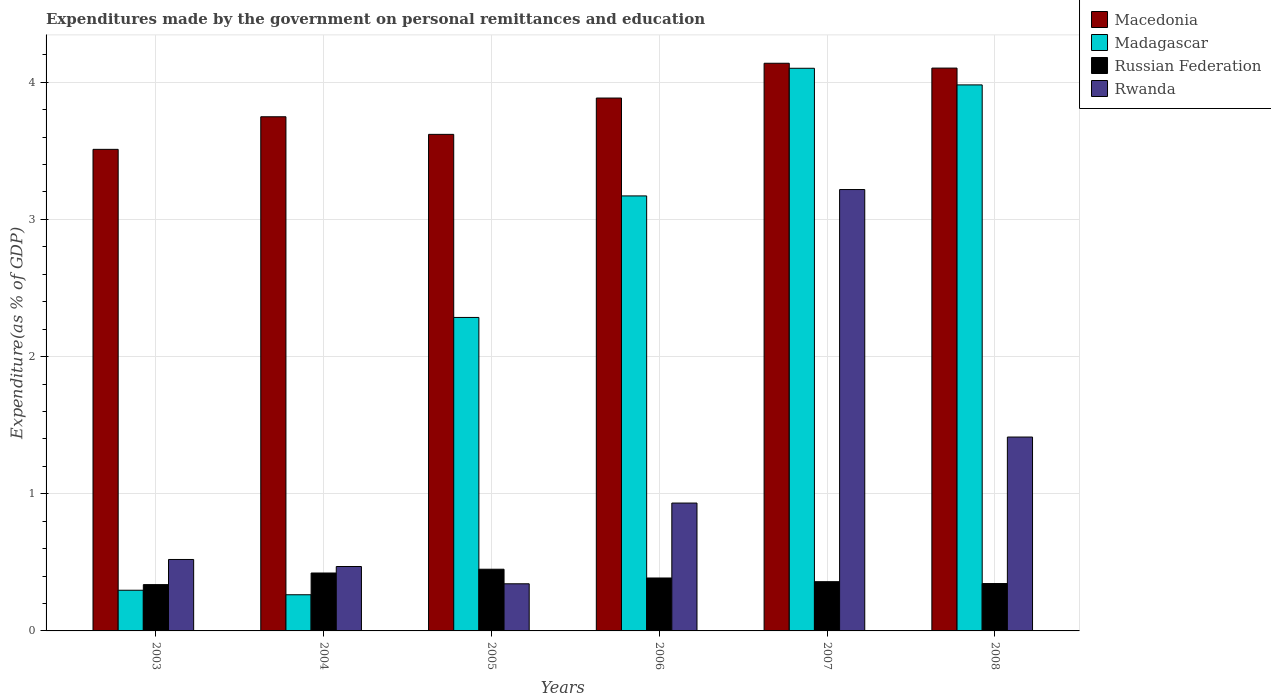How many different coloured bars are there?
Provide a succinct answer. 4. How many groups of bars are there?
Your answer should be compact. 6. How many bars are there on the 1st tick from the right?
Your answer should be very brief. 4. What is the expenditures made by the government on personal remittances and education in Rwanda in 2008?
Keep it short and to the point. 1.41. Across all years, what is the maximum expenditures made by the government on personal remittances and education in Macedonia?
Your response must be concise. 4.14. Across all years, what is the minimum expenditures made by the government on personal remittances and education in Rwanda?
Make the answer very short. 0.34. What is the total expenditures made by the government on personal remittances and education in Rwanda in the graph?
Offer a terse response. 6.9. What is the difference between the expenditures made by the government on personal remittances and education in Russian Federation in 2003 and that in 2008?
Your answer should be compact. -0.01. What is the difference between the expenditures made by the government on personal remittances and education in Russian Federation in 2005 and the expenditures made by the government on personal remittances and education in Madagascar in 2004?
Provide a short and direct response. 0.19. What is the average expenditures made by the government on personal remittances and education in Macedonia per year?
Offer a very short reply. 3.83. In the year 2008, what is the difference between the expenditures made by the government on personal remittances and education in Macedonia and expenditures made by the government on personal remittances and education in Madagascar?
Provide a short and direct response. 0.12. What is the ratio of the expenditures made by the government on personal remittances and education in Russian Federation in 2003 to that in 2004?
Give a very brief answer. 0.8. Is the difference between the expenditures made by the government on personal remittances and education in Macedonia in 2003 and 2006 greater than the difference between the expenditures made by the government on personal remittances and education in Madagascar in 2003 and 2006?
Provide a succinct answer. Yes. What is the difference between the highest and the second highest expenditures made by the government on personal remittances and education in Rwanda?
Ensure brevity in your answer.  1.8. What is the difference between the highest and the lowest expenditures made by the government on personal remittances and education in Russian Federation?
Give a very brief answer. 0.11. What does the 4th bar from the left in 2003 represents?
Keep it short and to the point. Rwanda. What does the 3rd bar from the right in 2006 represents?
Your answer should be compact. Madagascar. Are all the bars in the graph horizontal?
Offer a terse response. No. How many years are there in the graph?
Your response must be concise. 6. Are the values on the major ticks of Y-axis written in scientific E-notation?
Your answer should be very brief. No. Where does the legend appear in the graph?
Make the answer very short. Top right. What is the title of the graph?
Your response must be concise. Expenditures made by the government on personal remittances and education. Does "Malawi" appear as one of the legend labels in the graph?
Your answer should be very brief. No. What is the label or title of the Y-axis?
Ensure brevity in your answer.  Expenditure(as % of GDP). What is the Expenditure(as % of GDP) of Macedonia in 2003?
Your answer should be compact. 3.51. What is the Expenditure(as % of GDP) in Madagascar in 2003?
Your answer should be compact. 0.3. What is the Expenditure(as % of GDP) of Russian Federation in 2003?
Your response must be concise. 0.34. What is the Expenditure(as % of GDP) in Rwanda in 2003?
Make the answer very short. 0.52. What is the Expenditure(as % of GDP) of Macedonia in 2004?
Your response must be concise. 3.75. What is the Expenditure(as % of GDP) in Madagascar in 2004?
Provide a succinct answer. 0.26. What is the Expenditure(as % of GDP) in Russian Federation in 2004?
Make the answer very short. 0.42. What is the Expenditure(as % of GDP) in Rwanda in 2004?
Offer a terse response. 0.47. What is the Expenditure(as % of GDP) in Macedonia in 2005?
Make the answer very short. 3.62. What is the Expenditure(as % of GDP) of Madagascar in 2005?
Your response must be concise. 2.29. What is the Expenditure(as % of GDP) in Russian Federation in 2005?
Your response must be concise. 0.45. What is the Expenditure(as % of GDP) in Rwanda in 2005?
Make the answer very short. 0.34. What is the Expenditure(as % of GDP) in Macedonia in 2006?
Give a very brief answer. 3.88. What is the Expenditure(as % of GDP) in Madagascar in 2006?
Offer a very short reply. 3.17. What is the Expenditure(as % of GDP) in Russian Federation in 2006?
Your response must be concise. 0.39. What is the Expenditure(as % of GDP) of Rwanda in 2006?
Keep it short and to the point. 0.93. What is the Expenditure(as % of GDP) of Macedonia in 2007?
Make the answer very short. 4.14. What is the Expenditure(as % of GDP) of Madagascar in 2007?
Keep it short and to the point. 4.1. What is the Expenditure(as % of GDP) in Russian Federation in 2007?
Offer a very short reply. 0.36. What is the Expenditure(as % of GDP) of Rwanda in 2007?
Your answer should be compact. 3.22. What is the Expenditure(as % of GDP) of Macedonia in 2008?
Your answer should be compact. 4.1. What is the Expenditure(as % of GDP) in Madagascar in 2008?
Your answer should be compact. 3.98. What is the Expenditure(as % of GDP) of Russian Federation in 2008?
Your response must be concise. 0.35. What is the Expenditure(as % of GDP) in Rwanda in 2008?
Make the answer very short. 1.41. Across all years, what is the maximum Expenditure(as % of GDP) in Macedonia?
Offer a terse response. 4.14. Across all years, what is the maximum Expenditure(as % of GDP) in Madagascar?
Ensure brevity in your answer.  4.1. Across all years, what is the maximum Expenditure(as % of GDP) in Russian Federation?
Your response must be concise. 0.45. Across all years, what is the maximum Expenditure(as % of GDP) of Rwanda?
Provide a short and direct response. 3.22. Across all years, what is the minimum Expenditure(as % of GDP) of Macedonia?
Provide a short and direct response. 3.51. Across all years, what is the minimum Expenditure(as % of GDP) of Madagascar?
Offer a terse response. 0.26. Across all years, what is the minimum Expenditure(as % of GDP) of Russian Federation?
Offer a very short reply. 0.34. Across all years, what is the minimum Expenditure(as % of GDP) of Rwanda?
Make the answer very short. 0.34. What is the total Expenditure(as % of GDP) in Macedonia in the graph?
Your answer should be compact. 23.01. What is the total Expenditure(as % of GDP) in Madagascar in the graph?
Your response must be concise. 14.1. What is the total Expenditure(as % of GDP) in Russian Federation in the graph?
Provide a short and direct response. 2.3. What is the total Expenditure(as % of GDP) of Rwanda in the graph?
Offer a terse response. 6.9. What is the difference between the Expenditure(as % of GDP) in Macedonia in 2003 and that in 2004?
Your answer should be very brief. -0.24. What is the difference between the Expenditure(as % of GDP) of Madagascar in 2003 and that in 2004?
Provide a succinct answer. 0.03. What is the difference between the Expenditure(as % of GDP) of Russian Federation in 2003 and that in 2004?
Offer a terse response. -0.08. What is the difference between the Expenditure(as % of GDP) of Rwanda in 2003 and that in 2004?
Ensure brevity in your answer.  0.05. What is the difference between the Expenditure(as % of GDP) of Macedonia in 2003 and that in 2005?
Offer a terse response. -0.11. What is the difference between the Expenditure(as % of GDP) in Madagascar in 2003 and that in 2005?
Keep it short and to the point. -1.99. What is the difference between the Expenditure(as % of GDP) in Russian Federation in 2003 and that in 2005?
Provide a short and direct response. -0.11. What is the difference between the Expenditure(as % of GDP) in Rwanda in 2003 and that in 2005?
Offer a very short reply. 0.18. What is the difference between the Expenditure(as % of GDP) in Macedonia in 2003 and that in 2006?
Provide a short and direct response. -0.37. What is the difference between the Expenditure(as % of GDP) in Madagascar in 2003 and that in 2006?
Provide a succinct answer. -2.87. What is the difference between the Expenditure(as % of GDP) in Russian Federation in 2003 and that in 2006?
Make the answer very short. -0.05. What is the difference between the Expenditure(as % of GDP) of Rwanda in 2003 and that in 2006?
Ensure brevity in your answer.  -0.41. What is the difference between the Expenditure(as % of GDP) of Macedonia in 2003 and that in 2007?
Provide a succinct answer. -0.63. What is the difference between the Expenditure(as % of GDP) of Madagascar in 2003 and that in 2007?
Provide a succinct answer. -3.81. What is the difference between the Expenditure(as % of GDP) in Russian Federation in 2003 and that in 2007?
Give a very brief answer. -0.02. What is the difference between the Expenditure(as % of GDP) in Rwanda in 2003 and that in 2007?
Your response must be concise. -2.7. What is the difference between the Expenditure(as % of GDP) in Macedonia in 2003 and that in 2008?
Your answer should be compact. -0.59. What is the difference between the Expenditure(as % of GDP) of Madagascar in 2003 and that in 2008?
Offer a very short reply. -3.68. What is the difference between the Expenditure(as % of GDP) of Russian Federation in 2003 and that in 2008?
Keep it short and to the point. -0.01. What is the difference between the Expenditure(as % of GDP) in Rwanda in 2003 and that in 2008?
Your answer should be compact. -0.89. What is the difference between the Expenditure(as % of GDP) in Macedonia in 2004 and that in 2005?
Your answer should be compact. 0.13. What is the difference between the Expenditure(as % of GDP) of Madagascar in 2004 and that in 2005?
Your answer should be very brief. -2.02. What is the difference between the Expenditure(as % of GDP) of Russian Federation in 2004 and that in 2005?
Your answer should be very brief. -0.03. What is the difference between the Expenditure(as % of GDP) in Rwanda in 2004 and that in 2005?
Provide a short and direct response. 0.13. What is the difference between the Expenditure(as % of GDP) of Macedonia in 2004 and that in 2006?
Your answer should be compact. -0.14. What is the difference between the Expenditure(as % of GDP) in Madagascar in 2004 and that in 2006?
Give a very brief answer. -2.91. What is the difference between the Expenditure(as % of GDP) in Russian Federation in 2004 and that in 2006?
Your response must be concise. 0.04. What is the difference between the Expenditure(as % of GDP) in Rwanda in 2004 and that in 2006?
Give a very brief answer. -0.46. What is the difference between the Expenditure(as % of GDP) in Macedonia in 2004 and that in 2007?
Offer a terse response. -0.39. What is the difference between the Expenditure(as % of GDP) in Madagascar in 2004 and that in 2007?
Ensure brevity in your answer.  -3.84. What is the difference between the Expenditure(as % of GDP) in Russian Federation in 2004 and that in 2007?
Give a very brief answer. 0.06. What is the difference between the Expenditure(as % of GDP) in Rwanda in 2004 and that in 2007?
Ensure brevity in your answer.  -2.75. What is the difference between the Expenditure(as % of GDP) in Macedonia in 2004 and that in 2008?
Your response must be concise. -0.35. What is the difference between the Expenditure(as % of GDP) of Madagascar in 2004 and that in 2008?
Your response must be concise. -3.72. What is the difference between the Expenditure(as % of GDP) in Russian Federation in 2004 and that in 2008?
Your answer should be very brief. 0.08. What is the difference between the Expenditure(as % of GDP) of Rwanda in 2004 and that in 2008?
Make the answer very short. -0.94. What is the difference between the Expenditure(as % of GDP) of Macedonia in 2005 and that in 2006?
Your answer should be compact. -0.26. What is the difference between the Expenditure(as % of GDP) in Madagascar in 2005 and that in 2006?
Your answer should be very brief. -0.89. What is the difference between the Expenditure(as % of GDP) of Russian Federation in 2005 and that in 2006?
Ensure brevity in your answer.  0.06. What is the difference between the Expenditure(as % of GDP) of Rwanda in 2005 and that in 2006?
Provide a short and direct response. -0.59. What is the difference between the Expenditure(as % of GDP) in Macedonia in 2005 and that in 2007?
Offer a terse response. -0.52. What is the difference between the Expenditure(as % of GDP) in Madagascar in 2005 and that in 2007?
Provide a short and direct response. -1.82. What is the difference between the Expenditure(as % of GDP) of Russian Federation in 2005 and that in 2007?
Offer a terse response. 0.09. What is the difference between the Expenditure(as % of GDP) in Rwanda in 2005 and that in 2007?
Provide a succinct answer. -2.87. What is the difference between the Expenditure(as % of GDP) in Macedonia in 2005 and that in 2008?
Your answer should be compact. -0.48. What is the difference between the Expenditure(as % of GDP) in Madagascar in 2005 and that in 2008?
Provide a short and direct response. -1.7. What is the difference between the Expenditure(as % of GDP) of Russian Federation in 2005 and that in 2008?
Make the answer very short. 0.1. What is the difference between the Expenditure(as % of GDP) of Rwanda in 2005 and that in 2008?
Offer a very short reply. -1.07. What is the difference between the Expenditure(as % of GDP) in Macedonia in 2006 and that in 2007?
Offer a very short reply. -0.25. What is the difference between the Expenditure(as % of GDP) of Madagascar in 2006 and that in 2007?
Offer a terse response. -0.93. What is the difference between the Expenditure(as % of GDP) in Russian Federation in 2006 and that in 2007?
Make the answer very short. 0.03. What is the difference between the Expenditure(as % of GDP) of Rwanda in 2006 and that in 2007?
Offer a terse response. -2.29. What is the difference between the Expenditure(as % of GDP) in Macedonia in 2006 and that in 2008?
Give a very brief answer. -0.22. What is the difference between the Expenditure(as % of GDP) in Madagascar in 2006 and that in 2008?
Your answer should be very brief. -0.81. What is the difference between the Expenditure(as % of GDP) of Russian Federation in 2006 and that in 2008?
Your response must be concise. 0.04. What is the difference between the Expenditure(as % of GDP) in Rwanda in 2006 and that in 2008?
Ensure brevity in your answer.  -0.48. What is the difference between the Expenditure(as % of GDP) of Macedonia in 2007 and that in 2008?
Provide a short and direct response. 0.04. What is the difference between the Expenditure(as % of GDP) in Madagascar in 2007 and that in 2008?
Offer a very short reply. 0.12. What is the difference between the Expenditure(as % of GDP) of Russian Federation in 2007 and that in 2008?
Offer a very short reply. 0.01. What is the difference between the Expenditure(as % of GDP) in Rwanda in 2007 and that in 2008?
Your response must be concise. 1.8. What is the difference between the Expenditure(as % of GDP) in Macedonia in 2003 and the Expenditure(as % of GDP) in Madagascar in 2004?
Your response must be concise. 3.25. What is the difference between the Expenditure(as % of GDP) in Macedonia in 2003 and the Expenditure(as % of GDP) in Russian Federation in 2004?
Provide a short and direct response. 3.09. What is the difference between the Expenditure(as % of GDP) in Macedonia in 2003 and the Expenditure(as % of GDP) in Rwanda in 2004?
Your answer should be very brief. 3.04. What is the difference between the Expenditure(as % of GDP) of Madagascar in 2003 and the Expenditure(as % of GDP) of Russian Federation in 2004?
Offer a terse response. -0.13. What is the difference between the Expenditure(as % of GDP) of Madagascar in 2003 and the Expenditure(as % of GDP) of Rwanda in 2004?
Offer a very short reply. -0.17. What is the difference between the Expenditure(as % of GDP) in Russian Federation in 2003 and the Expenditure(as % of GDP) in Rwanda in 2004?
Offer a terse response. -0.13. What is the difference between the Expenditure(as % of GDP) of Macedonia in 2003 and the Expenditure(as % of GDP) of Madagascar in 2005?
Provide a short and direct response. 1.23. What is the difference between the Expenditure(as % of GDP) in Macedonia in 2003 and the Expenditure(as % of GDP) in Russian Federation in 2005?
Make the answer very short. 3.06. What is the difference between the Expenditure(as % of GDP) in Macedonia in 2003 and the Expenditure(as % of GDP) in Rwanda in 2005?
Your answer should be compact. 3.17. What is the difference between the Expenditure(as % of GDP) in Madagascar in 2003 and the Expenditure(as % of GDP) in Russian Federation in 2005?
Your answer should be compact. -0.15. What is the difference between the Expenditure(as % of GDP) in Madagascar in 2003 and the Expenditure(as % of GDP) in Rwanda in 2005?
Your answer should be compact. -0.05. What is the difference between the Expenditure(as % of GDP) of Russian Federation in 2003 and the Expenditure(as % of GDP) of Rwanda in 2005?
Make the answer very short. -0.01. What is the difference between the Expenditure(as % of GDP) of Macedonia in 2003 and the Expenditure(as % of GDP) of Madagascar in 2006?
Your answer should be very brief. 0.34. What is the difference between the Expenditure(as % of GDP) in Macedonia in 2003 and the Expenditure(as % of GDP) in Russian Federation in 2006?
Make the answer very short. 3.12. What is the difference between the Expenditure(as % of GDP) in Macedonia in 2003 and the Expenditure(as % of GDP) in Rwanda in 2006?
Your answer should be very brief. 2.58. What is the difference between the Expenditure(as % of GDP) in Madagascar in 2003 and the Expenditure(as % of GDP) in Russian Federation in 2006?
Give a very brief answer. -0.09. What is the difference between the Expenditure(as % of GDP) in Madagascar in 2003 and the Expenditure(as % of GDP) in Rwanda in 2006?
Offer a terse response. -0.64. What is the difference between the Expenditure(as % of GDP) of Russian Federation in 2003 and the Expenditure(as % of GDP) of Rwanda in 2006?
Your answer should be very brief. -0.59. What is the difference between the Expenditure(as % of GDP) of Macedonia in 2003 and the Expenditure(as % of GDP) of Madagascar in 2007?
Keep it short and to the point. -0.59. What is the difference between the Expenditure(as % of GDP) of Macedonia in 2003 and the Expenditure(as % of GDP) of Russian Federation in 2007?
Ensure brevity in your answer.  3.15. What is the difference between the Expenditure(as % of GDP) of Macedonia in 2003 and the Expenditure(as % of GDP) of Rwanda in 2007?
Offer a very short reply. 0.29. What is the difference between the Expenditure(as % of GDP) of Madagascar in 2003 and the Expenditure(as % of GDP) of Russian Federation in 2007?
Your answer should be compact. -0.06. What is the difference between the Expenditure(as % of GDP) of Madagascar in 2003 and the Expenditure(as % of GDP) of Rwanda in 2007?
Give a very brief answer. -2.92. What is the difference between the Expenditure(as % of GDP) of Russian Federation in 2003 and the Expenditure(as % of GDP) of Rwanda in 2007?
Give a very brief answer. -2.88. What is the difference between the Expenditure(as % of GDP) of Macedonia in 2003 and the Expenditure(as % of GDP) of Madagascar in 2008?
Your answer should be compact. -0.47. What is the difference between the Expenditure(as % of GDP) in Macedonia in 2003 and the Expenditure(as % of GDP) in Russian Federation in 2008?
Offer a terse response. 3.17. What is the difference between the Expenditure(as % of GDP) in Macedonia in 2003 and the Expenditure(as % of GDP) in Rwanda in 2008?
Make the answer very short. 2.1. What is the difference between the Expenditure(as % of GDP) in Madagascar in 2003 and the Expenditure(as % of GDP) in Russian Federation in 2008?
Your answer should be very brief. -0.05. What is the difference between the Expenditure(as % of GDP) in Madagascar in 2003 and the Expenditure(as % of GDP) in Rwanda in 2008?
Your answer should be very brief. -1.12. What is the difference between the Expenditure(as % of GDP) of Russian Federation in 2003 and the Expenditure(as % of GDP) of Rwanda in 2008?
Your answer should be very brief. -1.08. What is the difference between the Expenditure(as % of GDP) in Macedonia in 2004 and the Expenditure(as % of GDP) in Madagascar in 2005?
Your answer should be very brief. 1.46. What is the difference between the Expenditure(as % of GDP) of Macedonia in 2004 and the Expenditure(as % of GDP) of Russian Federation in 2005?
Provide a succinct answer. 3.3. What is the difference between the Expenditure(as % of GDP) in Macedonia in 2004 and the Expenditure(as % of GDP) in Rwanda in 2005?
Provide a short and direct response. 3.4. What is the difference between the Expenditure(as % of GDP) of Madagascar in 2004 and the Expenditure(as % of GDP) of Russian Federation in 2005?
Ensure brevity in your answer.  -0.19. What is the difference between the Expenditure(as % of GDP) in Madagascar in 2004 and the Expenditure(as % of GDP) in Rwanda in 2005?
Keep it short and to the point. -0.08. What is the difference between the Expenditure(as % of GDP) in Russian Federation in 2004 and the Expenditure(as % of GDP) in Rwanda in 2005?
Keep it short and to the point. 0.08. What is the difference between the Expenditure(as % of GDP) in Macedonia in 2004 and the Expenditure(as % of GDP) in Madagascar in 2006?
Give a very brief answer. 0.58. What is the difference between the Expenditure(as % of GDP) of Macedonia in 2004 and the Expenditure(as % of GDP) of Russian Federation in 2006?
Offer a very short reply. 3.36. What is the difference between the Expenditure(as % of GDP) of Macedonia in 2004 and the Expenditure(as % of GDP) of Rwanda in 2006?
Keep it short and to the point. 2.82. What is the difference between the Expenditure(as % of GDP) in Madagascar in 2004 and the Expenditure(as % of GDP) in Russian Federation in 2006?
Offer a terse response. -0.12. What is the difference between the Expenditure(as % of GDP) in Madagascar in 2004 and the Expenditure(as % of GDP) in Rwanda in 2006?
Offer a terse response. -0.67. What is the difference between the Expenditure(as % of GDP) in Russian Federation in 2004 and the Expenditure(as % of GDP) in Rwanda in 2006?
Give a very brief answer. -0.51. What is the difference between the Expenditure(as % of GDP) of Macedonia in 2004 and the Expenditure(as % of GDP) of Madagascar in 2007?
Provide a succinct answer. -0.35. What is the difference between the Expenditure(as % of GDP) in Macedonia in 2004 and the Expenditure(as % of GDP) in Russian Federation in 2007?
Make the answer very short. 3.39. What is the difference between the Expenditure(as % of GDP) in Macedonia in 2004 and the Expenditure(as % of GDP) in Rwanda in 2007?
Provide a succinct answer. 0.53. What is the difference between the Expenditure(as % of GDP) in Madagascar in 2004 and the Expenditure(as % of GDP) in Russian Federation in 2007?
Your response must be concise. -0.1. What is the difference between the Expenditure(as % of GDP) in Madagascar in 2004 and the Expenditure(as % of GDP) in Rwanda in 2007?
Your answer should be very brief. -2.95. What is the difference between the Expenditure(as % of GDP) of Russian Federation in 2004 and the Expenditure(as % of GDP) of Rwanda in 2007?
Offer a terse response. -2.8. What is the difference between the Expenditure(as % of GDP) of Macedonia in 2004 and the Expenditure(as % of GDP) of Madagascar in 2008?
Your answer should be compact. -0.23. What is the difference between the Expenditure(as % of GDP) of Macedonia in 2004 and the Expenditure(as % of GDP) of Russian Federation in 2008?
Provide a short and direct response. 3.4. What is the difference between the Expenditure(as % of GDP) of Macedonia in 2004 and the Expenditure(as % of GDP) of Rwanda in 2008?
Your answer should be compact. 2.33. What is the difference between the Expenditure(as % of GDP) of Madagascar in 2004 and the Expenditure(as % of GDP) of Russian Federation in 2008?
Make the answer very short. -0.08. What is the difference between the Expenditure(as % of GDP) in Madagascar in 2004 and the Expenditure(as % of GDP) in Rwanda in 2008?
Your response must be concise. -1.15. What is the difference between the Expenditure(as % of GDP) in Russian Federation in 2004 and the Expenditure(as % of GDP) in Rwanda in 2008?
Your answer should be very brief. -0.99. What is the difference between the Expenditure(as % of GDP) of Macedonia in 2005 and the Expenditure(as % of GDP) of Madagascar in 2006?
Ensure brevity in your answer.  0.45. What is the difference between the Expenditure(as % of GDP) in Macedonia in 2005 and the Expenditure(as % of GDP) in Russian Federation in 2006?
Ensure brevity in your answer.  3.23. What is the difference between the Expenditure(as % of GDP) of Macedonia in 2005 and the Expenditure(as % of GDP) of Rwanda in 2006?
Keep it short and to the point. 2.69. What is the difference between the Expenditure(as % of GDP) in Madagascar in 2005 and the Expenditure(as % of GDP) in Russian Federation in 2006?
Ensure brevity in your answer.  1.9. What is the difference between the Expenditure(as % of GDP) in Madagascar in 2005 and the Expenditure(as % of GDP) in Rwanda in 2006?
Offer a very short reply. 1.35. What is the difference between the Expenditure(as % of GDP) in Russian Federation in 2005 and the Expenditure(as % of GDP) in Rwanda in 2006?
Give a very brief answer. -0.48. What is the difference between the Expenditure(as % of GDP) in Macedonia in 2005 and the Expenditure(as % of GDP) in Madagascar in 2007?
Your answer should be very brief. -0.48. What is the difference between the Expenditure(as % of GDP) in Macedonia in 2005 and the Expenditure(as % of GDP) in Russian Federation in 2007?
Offer a very short reply. 3.26. What is the difference between the Expenditure(as % of GDP) in Macedonia in 2005 and the Expenditure(as % of GDP) in Rwanda in 2007?
Offer a very short reply. 0.4. What is the difference between the Expenditure(as % of GDP) in Madagascar in 2005 and the Expenditure(as % of GDP) in Russian Federation in 2007?
Provide a short and direct response. 1.93. What is the difference between the Expenditure(as % of GDP) of Madagascar in 2005 and the Expenditure(as % of GDP) of Rwanda in 2007?
Provide a short and direct response. -0.93. What is the difference between the Expenditure(as % of GDP) of Russian Federation in 2005 and the Expenditure(as % of GDP) of Rwanda in 2007?
Give a very brief answer. -2.77. What is the difference between the Expenditure(as % of GDP) in Macedonia in 2005 and the Expenditure(as % of GDP) in Madagascar in 2008?
Offer a terse response. -0.36. What is the difference between the Expenditure(as % of GDP) of Macedonia in 2005 and the Expenditure(as % of GDP) of Russian Federation in 2008?
Give a very brief answer. 3.27. What is the difference between the Expenditure(as % of GDP) in Macedonia in 2005 and the Expenditure(as % of GDP) in Rwanda in 2008?
Give a very brief answer. 2.21. What is the difference between the Expenditure(as % of GDP) of Madagascar in 2005 and the Expenditure(as % of GDP) of Russian Federation in 2008?
Offer a very short reply. 1.94. What is the difference between the Expenditure(as % of GDP) in Madagascar in 2005 and the Expenditure(as % of GDP) in Rwanda in 2008?
Provide a short and direct response. 0.87. What is the difference between the Expenditure(as % of GDP) of Russian Federation in 2005 and the Expenditure(as % of GDP) of Rwanda in 2008?
Offer a terse response. -0.96. What is the difference between the Expenditure(as % of GDP) in Macedonia in 2006 and the Expenditure(as % of GDP) in Madagascar in 2007?
Your answer should be very brief. -0.22. What is the difference between the Expenditure(as % of GDP) of Macedonia in 2006 and the Expenditure(as % of GDP) of Russian Federation in 2007?
Make the answer very short. 3.53. What is the difference between the Expenditure(as % of GDP) of Macedonia in 2006 and the Expenditure(as % of GDP) of Rwanda in 2007?
Keep it short and to the point. 0.67. What is the difference between the Expenditure(as % of GDP) of Madagascar in 2006 and the Expenditure(as % of GDP) of Russian Federation in 2007?
Ensure brevity in your answer.  2.81. What is the difference between the Expenditure(as % of GDP) in Madagascar in 2006 and the Expenditure(as % of GDP) in Rwanda in 2007?
Your answer should be compact. -0.05. What is the difference between the Expenditure(as % of GDP) in Russian Federation in 2006 and the Expenditure(as % of GDP) in Rwanda in 2007?
Keep it short and to the point. -2.83. What is the difference between the Expenditure(as % of GDP) in Macedonia in 2006 and the Expenditure(as % of GDP) in Madagascar in 2008?
Your answer should be very brief. -0.1. What is the difference between the Expenditure(as % of GDP) in Macedonia in 2006 and the Expenditure(as % of GDP) in Russian Federation in 2008?
Provide a short and direct response. 3.54. What is the difference between the Expenditure(as % of GDP) of Macedonia in 2006 and the Expenditure(as % of GDP) of Rwanda in 2008?
Offer a terse response. 2.47. What is the difference between the Expenditure(as % of GDP) of Madagascar in 2006 and the Expenditure(as % of GDP) of Russian Federation in 2008?
Your answer should be very brief. 2.83. What is the difference between the Expenditure(as % of GDP) in Madagascar in 2006 and the Expenditure(as % of GDP) in Rwanda in 2008?
Your answer should be very brief. 1.76. What is the difference between the Expenditure(as % of GDP) of Russian Federation in 2006 and the Expenditure(as % of GDP) of Rwanda in 2008?
Offer a very short reply. -1.03. What is the difference between the Expenditure(as % of GDP) of Macedonia in 2007 and the Expenditure(as % of GDP) of Madagascar in 2008?
Provide a succinct answer. 0.16. What is the difference between the Expenditure(as % of GDP) of Macedonia in 2007 and the Expenditure(as % of GDP) of Russian Federation in 2008?
Your response must be concise. 3.79. What is the difference between the Expenditure(as % of GDP) of Macedonia in 2007 and the Expenditure(as % of GDP) of Rwanda in 2008?
Give a very brief answer. 2.73. What is the difference between the Expenditure(as % of GDP) in Madagascar in 2007 and the Expenditure(as % of GDP) in Russian Federation in 2008?
Offer a terse response. 3.76. What is the difference between the Expenditure(as % of GDP) of Madagascar in 2007 and the Expenditure(as % of GDP) of Rwanda in 2008?
Your response must be concise. 2.69. What is the difference between the Expenditure(as % of GDP) of Russian Federation in 2007 and the Expenditure(as % of GDP) of Rwanda in 2008?
Offer a very short reply. -1.05. What is the average Expenditure(as % of GDP) in Macedonia per year?
Your response must be concise. 3.83. What is the average Expenditure(as % of GDP) of Madagascar per year?
Provide a succinct answer. 2.35. What is the average Expenditure(as % of GDP) in Russian Federation per year?
Keep it short and to the point. 0.38. What is the average Expenditure(as % of GDP) of Rwanda per year?
Keep it short and to the point. 1.15. In the year 2003, what is the difference between the Expenditure(as % of GDP) of Macedonia and Expenditure(as % of GDP) of Madagascar?
Your answer should be very brief. 3.21. In the year 2003, what is the difference between the Expenditure(as % of GDP) in Macedonia and Expenditure(as % of GDP) in Russian Federation?
Offer a very short reply. 3.17. In the year 2003, what is the difference between the Expenditure(as % of GDP) of Macedonia and Expenditure(as % of GDP) of Rwanda?
Give a very brief answer. 2.99. In the year 2003, what is the difference between the Expenditure(as % of GDP) of Madagascar and Expenditure(as % of GDP) of Russian Federation?
Ensure brevity in your answer.  -0.04. In the year 2003, what is the difference between the Expenditure(as % of GDP) in Madagascar and Expenditure(as % of GDP) in Rwanda?
Provide a succinct answer. -0.22. In the year 2003, what is the difference between the Expenditure(as % of GDP) in Russian Federation and Expenditure(as % of GDP) in Rwanda?
Give a very brief answer. -0.18. In the year 2004, what is the difference between the Expenditure(as % of GDP) of Macedonia and Expenditure(as % of GDP) of Madagascar?
Keep it short and to the point. 3.48. In the year 2004, what is the difference between the Expenditure(as % of GDP) in Macedonia and Expenditure(as % of GDP) in Russian Federation?
Your response must be concise. 3.33. In the year 2004, what is the difference between the Expenditure(as % of GDP) in Macedonia and Expenditure(as % of GDP) in Rwanda?
Provide a succinct answer. 3.28. In the year 2004, what is the difference between the Expenditure(as % of GDP) in Madagascar and Expenditure(as % of GDP) in Russian Federation?
Your response must be concise. -0.16. In the year 2004, what is the difference between the Expenditure(as % of GDP) of Madagascar and Expenditure(as % of GDP) of Rwanda?
Make the answer very short. -0.21. In the year 2004, what is the difference between the Expenditure(as % of GDP) in Russian Federation and Expenditure(as % of GDP) in Rwanda?
Offer a terse response. -0.05. In the year 2005, what is the difference between the Expenditure(as % of GDP) in Macedonia and Expenditure(as % of GDP) in Madagascar?
Your response must be concise. 1.33. In the year 2005, what is the difference between the Expenditure(as % of GDP) in Macedonia and Expenditure(as % of GDP) in Russian Federation?
Offer a very short reply. 3.17. In the year 2005, what is the difference between the Expenditure(as % of GDP) of Macedonia and Expenditure(as % of GDP) of Rwanda?
Your answer should be compact. 3.28. In the year 2005, what is the difference between the Expenditure(as % of GDP) of Madagascar and Expenditure(as % of GDP) of Russian Federation?
Offer a terse response. 1.84. In the year 2005, what is the difference between the Expenditure(as % of GDP) of Madagascar and Expenditure(as % of GDP) of Rwanda?
Provide a short and direct response. 1.94. In the year 2005, what is the difference between the Expenditure(as % of GDP) in Russian Federation and Expenditure(as % of GDP) in Rwanda?
Keep it short and to the point. 0.11. In the year 2006, what is the difference between the Expenditure(as % of GDP) of Macedonia and Expenditure(as % of GDP) of Madagascar?
Provide a succinct answer. 0.71. In the year 2006, what is the difference between the Expenditure(as % of GDP) of Macedonia and Expenditure(as % of GDP) of Russian Federation?
Provide a succinct answer. 3.5. In the year 2006, what is the difference between the Expenditure(as % of GDP) in Macedonia and Expenditure(as % of GDP) in Rwanda?
Ensure brevity in your answer.  2.95. In the year 2006, what is the difference between the Expenditure(as % of GDP) of Madagascar and Expenditure(as % of GDP) of Russian Federation?
Provide a succinct answer. 2.79. In the year 2006, what is the difference between the Expenditure(as % of GDP) of Madagascar and Expenditure(as % of GDP) of Rwanda?
Offer a terse response. 2.24. In the year 2006, what is the difference between the Expenditure(as % of GDP) in Russian Federation and Expenditure(as % of GDP) in Rwanda?
Ensure brevity in your answer.  -0.55. In the year 2007, what is the difference between the Expenditure(as % of GDP) of Macedonia and Expenditure(as % of GDP) of Madagascar?
Your response must be concise. 0.04. In the year 2007, what is the difference between the Expenditure(as % of GDP) in Macedonia and Expenditure(as % of GDP) in Russian Federation?
Offer a terse response. 3.78. In the year 2007, what is the difference between the Expenditure(as % of GDP) of Macedonia and Expenditure(as % of GDP) of Rwanda?
Give a very brief answer. 0.92. In the year 2007, what is the difference between the Expenditure(as % of GDP) in Madagascar and Expenditure(as % of GDP) in Russian Federation?
Offer a very short reply. 3.74. In the year 2007, what is the difference between the Expenditure(as % of GDP) of Madagascar and Expenditure(as % of GDP) of Rwanda?
Ensure brevity in your answer.  0.88. In the year 2007, what is the difference between the Expenditure(as % of GDP) in Russian Federation and Expenditure(as % of GDP) in Rwanda?
Provide a short and direct response. -2.86. In the year 2008, what is the difference between the Expenditure(as % of GDP) in Macedonia and Expenditure(as % of GDP) in Madagascar?
Your response must be concise. 0.12. In the year 2008, what is the difference between the Expenditure(as % of GDP) in Macedonia and Expenditure(as % of GDP) in Russian Federation?
Ensure brevity in your answer.  3.76. In the year 2008, what is the difference between the Expenditure(as % of GDP) in Macedonia and Expenditure(as % of GDP) in Rwanda?
Keep it short and to the point. 2.69. In the year 2008, what is the difference between the Expenditure(as % of GDP) of Madagascar and Expenditure(as % of GDP) of Russian Federation?
Offer a very short reply. 3.64. In the year 2008, what is the difference between the Expenditure(as % of GDP) of Madagascar and Expenditure(as % of GDP) of Rwanda?
Offer a very short reply. 2.57. In the year 2008, what is the difference between the Expenditure(as % of GDP) in Russian Federation and Expenditure(as % of GDP) in Rwanda?
Make the answer very short. -1.07. What is the ratio of the Expenditure(as % of GDP) of Macedonia in 2003 to that in 2004?
Your answer should be compact. 0.94. What is the ratio of the Expenditure(as % of GDP) in Madagascar in 2003 to that in 2004?
Provide a succinct answer. 1.12. What is the ratio of the Expenditure(as % of GDP) in Russian Federation in 2003 to that in 2004?
Keep it short and to the point. 0.8. What is the ratio of the Expenditure(as % of GDP) in Rwanda in 2003 to that in 2004?
Make the answer very short. 1.11. What is the ratio of the Expenditure(as % of GDP) in Macedonia in 2003 to that in 2005?
Ensure brevity in your answer.  0.97. What is the ratio of the Expenditure(as % of GDP) in Madagascar in 2003 to that in 2005?
Your answer should be very brief. 0.13. What is the ratio of the Expenditure(as % of GDP) of Russian Federation in 2003 to that in 2005?
Your answer should be compact. 0.75. What is the ratio of the Expenditure(as % of GDP) of Rwanda in 2003 to that in 2005?
Keep it short and to the point. 1.52. What is the ratio of the Expenditure(as % of GDP) of Macedonia in 2003 to that in 2006?
Your answer should be very brief. 0.9. What is the ratio of the Expenditure(as % of GDP) of Madagascar in 2003 to that in 2006?
Keep it short and to the point. 0.09. What is the ratio of the Expenditure(as % of GDP) of Russian Federation in 2003 to that in 2006?
Offer a terse response. 0.87. What is the ratio of the Expenditure(as % of GDP) in Rwanda in 2003 to that in 2006?
Offer a terse response. 0.56. What is the ratio of the Expenditure(as % of GDP) in Macedonia in 2003 to that in 2007?
Ensure brevity in your answer.  0.85. What is the ratio of the Expenditure(as % of GDP) in Madagascar in 2003 to that in 2007?
Make the answer very short. 0.07. What is the ratio of the Expenditure(as % of GDP) in Russian Federation in 2003 to that in 2007?
Provide a short and direct response. 0.94. What is the ratio of the Expenditure(as % of GDP) in Rwanda in 2003 to that in 2007?
Give a very brief answer. 0.16. What is the ratio of the Expenditure(as % of GDP) of Macedonia in 2003 to that in 2008?
Give a very brief answer. 0.86. What is the ratio of the Expenditure(as % of GDP) in Madagascar in 2003 to that in 2008?
Your answer should be very brief. 0.07. What is the ratio of the Expenditure(as % of GDP) of Russian Federation in 2003 to that in 2008?
Give a very brief answer. 0.98. What is the ratio of the Expenditure(as % of GDP) in Rwanda in 2003 to that in 2008?
Give a very brief answer. 0.37. What is the ratio of the Expenditure(as % of GDP) in Macedonia in 2004 to that in 2005?
Offer a terse response. 1.04. What is the ratio of the Expenditure(as % of GDP) of Madagascar in 2004 to that in 2005?
Give a very brief answer. 0.12. What is the ratio of the Expenditure(as % of GDP) in Russian Federation in 2004 to that in 2005?
Provide a short and direct response. 0.94. What is the ratio of the Expenditure(as % of GDP) of Rwanda in 2004 to that in 2005?
Your answer should be compact. 1.37. What is the ratio of the Expenditure(as % of GDP) of Macedonia in 2004 to that in 2006?
Make the answer very short. 0.96. What is the ratio of the Expenditure(as % of GDP) of Madagascar in 2004 to that in 2006?
Provide a succinct answer. 0.08. What is the ratio of the Expenditure(as % of GDP) in Russian Federation in 2004 to that in 2006?
Make the answer very short. 1.09. What is the ratio of the Expenditure(as % of GDP) of Rwanda in 2004 to that in 2006?
Your response must be concise. 0.5. What is the ratio of the Expenditure(as % of GDP) in Macedonia in 2004 to that in 2007?
Provide a succinct answer. 0.91. What is the ratio of the Expenditure(as % of GDP) of Madagascar in 2004 to that in 2007?
Your answer should be compact. 0.06. What is the ratio of the Expenditure(as % of GDP) in Russian Federation in 2004 to that in 2007?
Make the answer very short. 1.18. What is the ratio of the Expenditure(as % of GDP) in Rwanda in 2004 to that in 2007?
Keep it short and to the point. 0.15. What is the ratio of the Expenditure(as % of GDP) of Macedonia in 2004 to that in 2008?
Offer a very short reply. 0.91. What is the ratio of the Expenditure(as % of GDP) of Madagascar in 2004 to that in 2008?
Provide a succinct answer. 0.07. What is the ratio of the Expenditure(as % of GDP) in Russian Federation in 2004 to that in 2008?
Your response must be concise. 1.22. What is the ratio of the Expenditure(as % of GDP) in Rwanda in 2004 to that in 2008?
Your response must be concise. 0.33. What is the ratio of the Expenditure(as % of GDP) of Macedonia in 2005 to that in 2006?
Give a very brief answer. 0.93. What is the ratio of the Expenditure(as % of GDP) in Madagascar in 2005 to that in 2006?
Provide a succinct answer. 0.72. What is the ratio of the Expenditure(as % of GDP) of Russian Federation in 2005 to that in 2006?
Your answer should be compact. 1.17. What is the ratio of the Expenditure(as % of GDP) of Rwanda in 2005 to that in 2006?
Your answer should be very brief. 0.37. What is the ratio of the Expenditure(as % of GDP) of Macedonia in 2005 to that in 2007?
Your answer should be very brief. 0.87. What is the ratio of the Expenditure(as % of GDP) of Madagascar in 2005 to that in 2007?
Your response must be concise. 0.56. What is the ratio of the Expenditure(as % of GDP) in Russian Federation in 2005 to that in 2007?
Keep it short and to the point. 1.25. What is the ratio of the Expenditure(as % of GDP) in Rwanda in 2005 to that in 2007?
Give a very brief answer. 0.11. What is the ratio of the Expenditure(as % of GDP) of Macedonia in 2005 to that in 2008?
Offer a terse response. 0.88. What is the ratio of the Expenditure(as % of GDP) in Madagascar in 2005 to that in 2008?
Give a very brief answer. 0.57. What is the ratio of the Expenditure(as % of GDP) in Russian Federation in 2005 to that in 2008?
Your answer should be compact. 1.3. What is the ratio of the Expenditure(as % of GDP) of Rwanda in 2005 to that in 2008?
Give a very brief answer. 0.24. What is the ratio of the Expenditure(as % of GDP) of Macedonia in 2006 to that in 2007?
Offer a very short reply. 0.94. What is the ratio of the Expenditure(as % of GDP) in Madagascar in 2006 to that in 2007?
Offer a very short reply. 0.77. What is the ratio of the Expenditure(as % of GDP) in Russian Federation in 2006 to that in 2007?
Your response must be concise. 1.07. What is the ratio of the Expenditure(as % of GDP) of Rwanda in 2006 to that in 2007?
Give a very brief answer. 0.29. What is the ratio of the Expenditure(as % of GDP) of Macedonia in 2006 to that in 2008?
Your response must be concise. 0.95. What is the ratio of the Expenditure(as % of GDP) of Madagascar in 2006 to that in 2008?
Provide a short and direct response. 0.8. What is the ratio of the Expenditure(as % of GDP) of Russian Federation in 2006 to that in 2008?
Your answer should be very brief. 1.12. What is the ratio of the Expenditure(as % of GDP) in Rwanda in 2006 to that in 2008?
Ensure brevity in your answer.  0.66. What is the ratio of the Expenditure(as % of GDP) in Macedonia in 2007 to that in 2008?
Your answer should be very brief. 1.01. What is the ratio of the Expenditure(as % of GDP) of Madagascar in 2007 to that in 2008?
Offer a terse response. 1.03. What is the ratio of the Expenditure(as % of GDP) of Russian Federation in 2007 to that in 2008?
Your response must be concise. 1.04. What is the ratio of the Expenditure(as % of GDP) of Rwanda in 2007 to that in 2008?
Your answer should be very brief. 2.28. What is the difference between the highest and the second highest Expenditure(as % of GDP) in Macedonia?
Make the answer very short. 0.04. What is the difference between the highest and the second highest Expenditure(as % of GDP) in Madagascar?
Provide a succinct answer. 0.12. What is the difference between the highest and the second highest Expenditure(as % of GDP) in Russian Federation?
Provide a succinct answer. 0.03. What is the difference between the highest and the second highest Expenditure(as % of GDP) in Rwanda?
Provide a short and direct response. 1.8. What is the difference between the highest and the lowest Expenditure(as % of GDP) in Macedonia?
Your response must be concise. 0.63. What is the difference between the highest and the lowest Expenditure(as % of GDP) of Madagascar?
Give a very brief answer. 3.84. What is the difference between the highest and the lowest Expenditure(as % of GDP) in Russian Federation?
Ensure brevity in your answer.  0.11. What is the difference between the highest and the lowest Expenditure(as % of GDP) of Rwanda?
Keep it short and to the point. 2.87. 